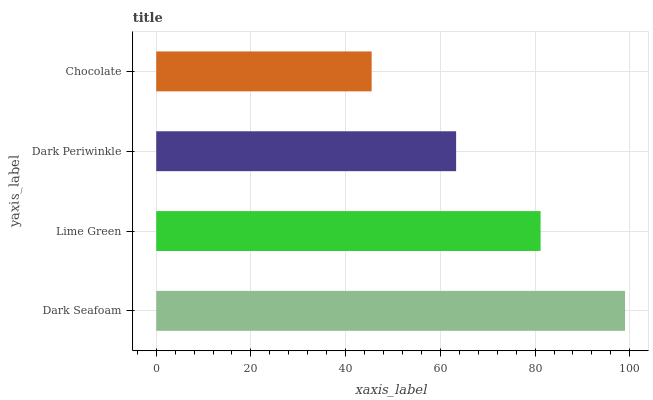Is Chocolate the minimum?
Answer yes or no. Yes. Is Dark Seafoam the maximum?
Answer yes or no. Yes. Is Lime Green the minimum?
Answer yes or no. No. Is Lime Green the maximum?
Answer yes or no. No. Is Dark Seafoam greater than Lime Green?
Answer yes or no. Yes. Is Lime Green less than Dark Seafoam?
Answer yes or no. Yes. Is Lime Green greater than Dark Seafoam?
Answer yes or no. No. Is Dark Seafoam less than Lime Green?
Answer yes or no. No. Is Lime Green the high median?
Answer yes or no. Yes. Is Dark Periwinkle the low median?
Answer yes or no. Yes. Is Chocolate the high median?
Answer yes or no. No. Is Dark Seafoam the low median?
Answer yes or no. No. 